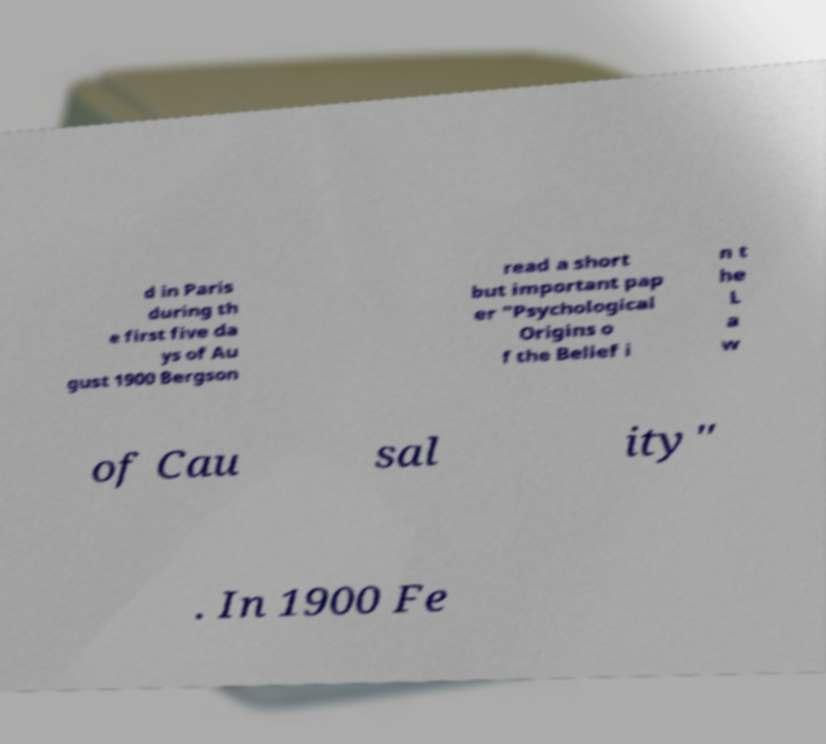I need the written content from this picture converted into text. Can you do that? d in Paris during th e first five da ys of Au gust 1900 Bergson read a short but important pap er "Psychological Origins o f the Belief i n t he L a w of Cau sal ity" . In 1900 Fe 